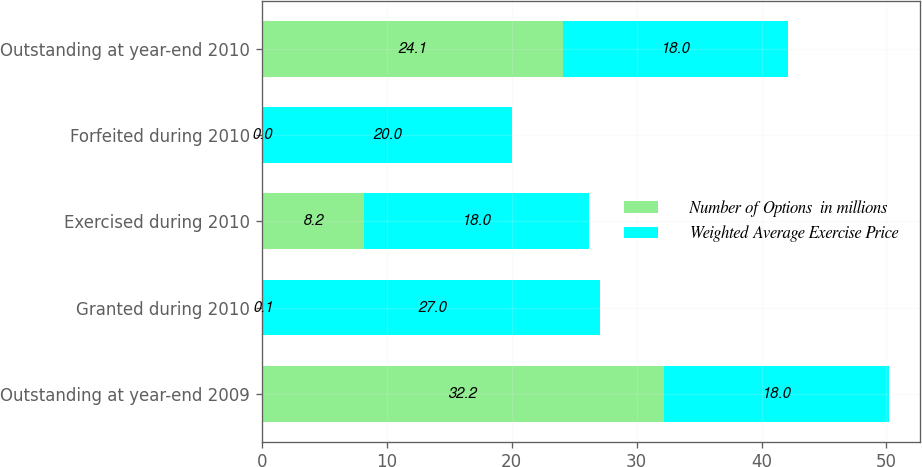Convert chart. <chart><loc_0><loc_0><loc_500><loc_500><stacked_bar_chart><ecel><fcel>Outstanding at year-end 2009<fcel>Granted during 2010<fcel>Exercised during 2010<fcel>Forfeited during 2010<fcel>Outstanding at year-end 2010<nl><fcel>Number of Options  in millions<fcel>32.2<fcel>0.1<fcel>8.2<fcel>0<fcel>24.1<nl><fcel>Weighted Average Exercise Price<fcel>18<fcel>27<fcel>18<fcel>20<fcel>18<nl></chart> 